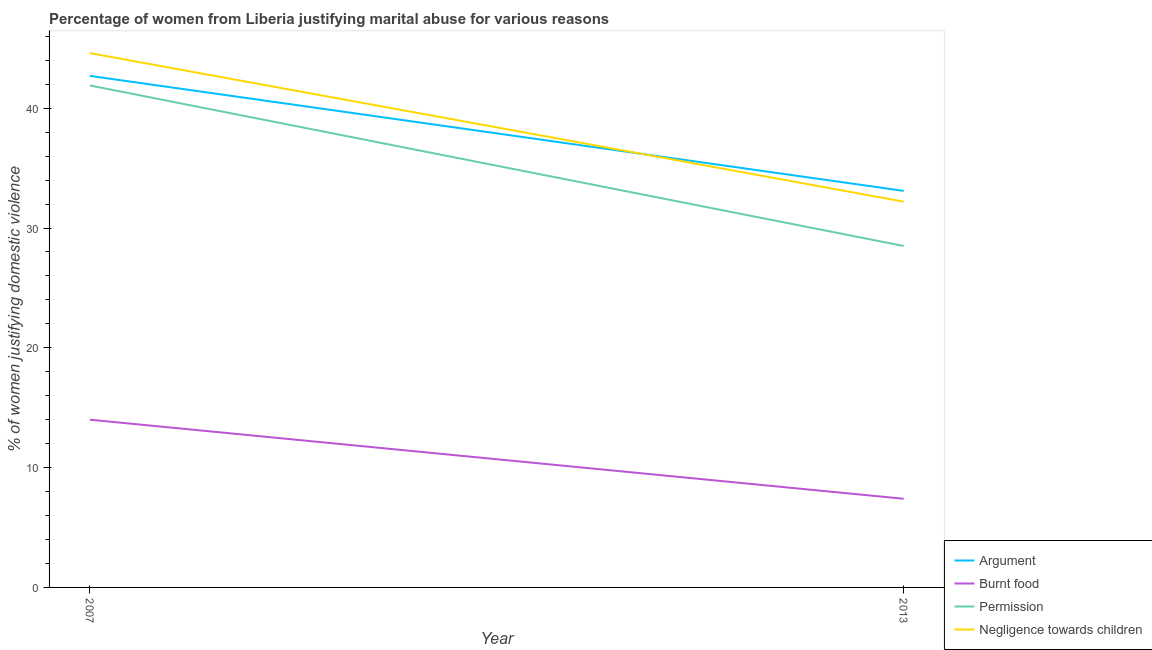Does the line corresponding to percentage of women justifying abuse for showing negligence towards children intersect with the line corresponding to percentage of women justifying abuse in the case of an argument?
Your answer should be very brief. Yes. What is the percentage of women justifying abuse for showing negligence towards children in 2007?
Offer a terse response. 44.6. Across all years, what is the maximum percentage of women justifying abuse for burning food?
Offer a terse response. 14. In which year was the percentage of women justifying abuse for showing negligence towards children maximum?
Provide a short and direct response. 2007. What is the total percentage of women justifying abuse for burning food in the graph?
Offer a very short reply. 21.4. What is the difference between the percentage of women justifying abuse for showing negligence towards children in 2007 and that in 2013?
Provide a succinct answer. 12.4. What is the difference between the percentage of women justifying abuse for burning food in 2007 and the percentage of women justifying abuse for going without permission in 2013?
Your answer should be compact. -14.5. What is the average percentage of women justifying abuse for showing negligence towards children per year?
Make the answer very short. 38.4. In the year 2007, what is the difference between the percentage of women justifying abuse in the case of an argument and percentage of women justifying abuse for burning food?
Provide a short and direct response. 28.7. In how many years, is the percentage of women justifying abuse for going without permission greater than 40 %?
Your answer should be compact. 1. What is the ratio of the percentage of women justifying abuse in the case of an argument in 2007 to that in 2013?
Keep it short and to the point. 1.29. In how many years, is the percentage of women justifying abuse for going without permission greater than the average percentage of women justifying abuse for going without permission taken over all years?
Offer a very short reply. 1. Is it the case that in every year, the sum of the percentage of women justifying abuse for showing negligence towards children and percentage of women justifying abuse for going without permission is greater than the sum of percentage of women justifying abuse for burning food and percentage of women justifying abuse in the case of an argument?
Provide a succinct answer. Yes. Is the percentage of women justifying abuse in the case of an argument strictly greater than the percentage of women justifying abuse for showing negligence towards children over the years?
Make the answer very short. No. How many lines are there?
Your response must be concise. 4. What is the difference between two consecutive major ticks on the Y-axis?
Your answer should be compact. 10. Are the values on the major ticks of Y-axis written in scientific E-notation?
Keep it short and to the point. No. Does the graph contain any zero values?
Make the answer very short. No. Does the graph contain grids?
Offer a very short reply. No. How many legend labels are there?
Your answer should be very brief. 4. What is the title of the graph?
Give a very brief answer. Percentage of women from Liberia justifying marital abuse for various reasons. What is the label or title of the Y-axis?
Make the answer very short. % of women justifying domestic violence. What is the % of women justifying domestic violence in Argument in 2007?
Keep it short and to the point. 42.7. What is the % of women justifying domestic violence of Permission in 2007?
Make the answer very short. 41.9. What is the % of women justifying domestic violence in Negligence towards children in 2007?
Offer a very short reply. 44.6. What is the % of women justifying domestic violence in Argument in 2013?
Your answer should be compact. 33.1. What is the % of women justifying domestic violence in Negligence towards children in 2013?
Your response must be concise. 32.2. Across all years, what is the maximum % of women justifying domestic violence of Argument?
Your answer should be compact. 42.7. Across all years, what is the maximum % of women justifying domestic violence in Burnt food?
Your answer should be very brief. 14. Across all years, what is the maximum % of women justifying domestic violence in Permission?
Your response must be concise. 41.9. Across all years, what is the maximum % of women justifying domestic violence in Negligence towards children?
Your answer should be very brief. 44.6. Across all years, what is the minimum % of women justifying domestic violence in Argument?
Your response must be concise. 33.1. Across all years, what is the minimum % of women justifying domestic violence of Burnt food?
Give a very brief answer. 7.4. Across all years, what is the minimum % of women justifying domestic violence of Negligence towards children?
Offer a terse response. 32.2. What is the total % of women justifying domestic violence in Argument in the graph?
Provide a short and direct response. 75.8. What is the total % of women justifying domestic violence in Burnt food in the graph?
Ensure brevity in your answer.  21.4. What is the total % of women justifying domestic violence of Permission in the graph?
Provide a short and direct response. 70.4. What is the total % of women justifying domestic violence of Negligence towards children in the graph?
Provide a succinct answer. 76.8. What is the difference between the % of women justifying domestic violence in Burnt food in 2007 and that in 2013?
Give a very brief answer. 6.6. What is the difference between the % of women justifying domestic violence in Permission in 2007 and that in 2013?
Offer a very short reply. 13.4. What is the difference between the % of women justifying domestic violence in Negligence towards children in 2007 and that in 2013?
Make the answer very short. 12.4. What is the difference between the % of women justifying domestic violence of Argument in 2007 and the % of women justifying domestic violence of Burnt food in 2013?
Your response must be concise. 35.3. What is the difference between the % of women justifying domestic violence in Argument in 2007 and the % of women justifying domestic violence in Permission in 2013?
Provide a succinct answer. 14.2. What is the difference between the % of women justifying domestic violence in Argument in 2007 and the % of women justifying domestic violence in Negligence towards children in 2013?
Keep it short and to the point. 10.5. What is the difference between the % of women justifying domestic violence of Burnt food in 2007 and the % of women justifying domestic violence of Permission in 2013?
Provide a succinct answer. -14.5. What is the difference between the % of women justifying domestic violence in Burnt food in 2007 and the % of women justifying domestic violence in Negligence towards children in 2013?
Offer a very short reply. -18.2. What is the difference between the % of women justifying domestic violence of Permission in 2007 and the % of women justifying domestic violence of Negligence towards children in 2013?
Offer a terse response. 9.7. What is the average % of women justifying domestic violence of Argument per year?
Your response must be concise. 37.9. What is the average % of women justifying domestic violence of Permission per year?
Offer a terse response. 35.2. What is the average % of women justifying domestic violence in Negligence towards children per year?
Your answer should be very brief. 38.4. In the year 2007, what is the difference between the % of women justifying domestic violence of Argument and % of women justifying domestic violence of Burnt food?
Your answer should be very brief. 28.7. In the year 2007, what is the difference between the % of women justifying domestic violence of Argument and % of women justifying domestic violence of Permission?
Make the answer very short. 0.8. In the year 2007, what is the difference between the % of women justifying domestic violence in Burnt food and % of women justifying domestic violence in Permission?
Give a very brief answer. -27.9. In the year 2007, what is the difference between the % of women justifying domestic violence of Burnt food and % of women justifying domestic violence of Negligence towards children?
Ensure brevity in your answer.  -30.6. In the year 2007, what is the difference between the % of women justifying domestic violence of Permission and % of women justifying domestic violence of Negligence towards children?
Offer a very short reply. -2.7. In the year 2013, what is the difference between the % of women justifying domestic violence of Argument and % of women justifying domestic violence of Burnt food?
Keep it short and to the point. 25.7. In the year 2013, what is the difference between the % of women justifying domestic violence of Argument and % of women justifying domestic violence of Permission?
Make the answer very short. 4.6. In the year 2013, what is the difference between the % of women justifying domestic violence of Argument and % of women justifying domestic violence of Negligence towards children?
Provide a short and direct response. 0.9. In the year 2013, what is the difference between the % of women justifying domestic violence of Burnt food and % of women justifying domestic violence of Permission?
Your answer should be compact. -21.1. In the year 2013, what is the difference between the % of women justifying domestic violence of Burnt food and % of women justifying domestic violence of Negligence towards children?
Offer a terse response. -24.8. What is the ratio of the % of women justifying domestic violence in Argument in 2007 to that in 2013?
Your answer should be very brief. 1.29. What is the ratio of the % of women justifying domestic violence of Burnt food in 2007 to that in 2013?
Your response must be concise. 1.89. What is the ratio of the % of women justifying domestic violence in Permission in 2007 to that in 2013?
Make the answer very short. 1.47. What is the ratio of the % of women justifying domestic violence in Negligence towards children in 2007 to that in 2013?
Your answer should be compact. 1.39. What is the difference between the highest and the second highest % of women justifying domestic violence of Burnt food?
Provide a succinct answer. 6.6. What is the difference between the highest and the second highest % of women justifying domestic violence of Negligence towards children?
Make the answer very short. 12.4. What is the difference between the highest and the lowest % of women justifying domestic violence in Argument?
Keep it short and to the point. 9.6. What is the difference between the highest and the lowest % of women justifying domestic violence in Burnt food?
Ensure brevity in your answer.  6.6. What is the difference between the highest and the lowest % of women justifying domestic violence of Negligence towards children?
Provide a succinct answer. 12.4. 